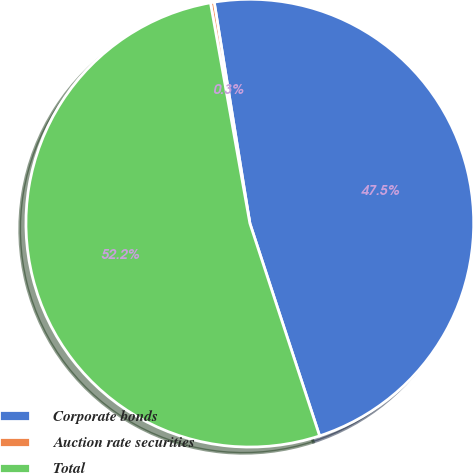Convert chart. <chart><loc_0><loc_0><loc_500><loc_500><pie_chart><fcel>Corporate bonds<fcel>Auction rate securities<fcel>Total<nl><fcel>47.5%<fcel>0.27%<fcel>52.23%<nl></chart> 